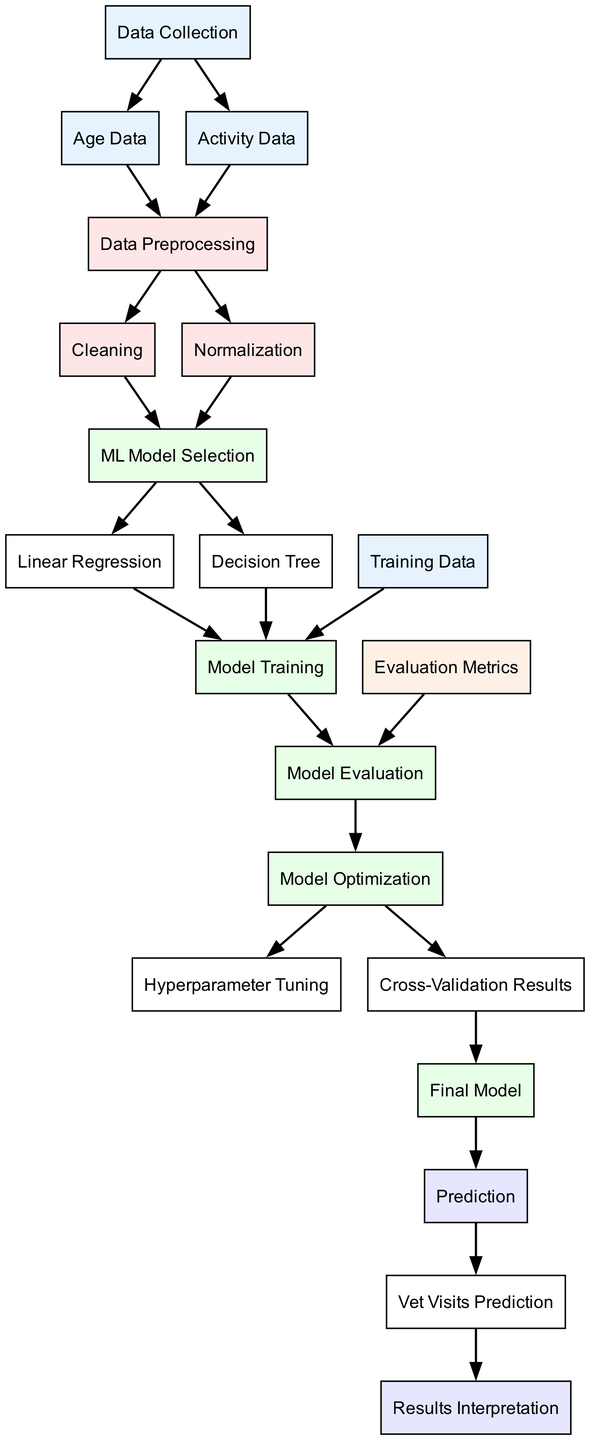What are the two types of data collected? The diagram specifies "Age Data" and "Activity Data" as the two types of data collected from dogs. These nodes originate directly from the "Data Collection" node, indicating they are the primary data inputs for further analysis.
Answer: Age Data, Activity Data How many nodes are present in the diagram? By counting all the individual nodes represented in the diagram, we find that there are a total of 17 nodes, ranging from "Data Collection" to "Results Interpretation".
Answer: 17 What is the purpose of the "Model Evaluation" node? The "Model Evaluation" node comprises the step where various model metrics are assessed. It connects the "Model Training" node and the "Model Optimization" node, indicating it’s crucial for determining the effectiveness of the trained model.
Answer: Evaluate models Which algorithm comes before "Model Training"? The "Model Selection" node leads to the choice of the algorithms: "Linear Regression" and "Decision Tree." Since both come before any training occurs, they collectively serve as the precursor to "Model Training".
Answer: Linear Regression, Decision Tree What is the next step after "Final Model"? Once the "Final Model" is created, the subsequent process is to make "Prediction." Thus, this indicates that predictions will be generated based on the final optimized model outputs.
Answer: Prediction Which node represents the input that leads to the prediction of vet visits? The "Prediction" node leads directly to "Vet Visits Prediction", identifying it as the specific output that quantifies the estimated vet visits based on previous data inputs and analysis.
Answer: Vet Visits Prediction How does "Cleaning" connect to the next process? The "Cleaning" node directly connects to "ML Model Selection," which means once data cleaning is complete, the next logical step is choosing the appropriate machine learning algorithms for modeling.
Answer: ML Model Selection What type of models are selected in the "ML Model Selection" node? The "ML Model Selection" node leads to "Linear Regression" and "Decision Tree," indicating these are the chosen models used for predicting outcomes based on the dataset processed earlier.
Answer: Linear Regression, Decision Tree What is the role of "Hyperparameter Tuning"? "Hyperparameter Tuning" is part of the "Model Optimization" phase, which involves fine-tuning the model parameters to improve performance. It is essential for enhancing the accuracy and effectiveness of the selected model.
Answer: Improve model performance 